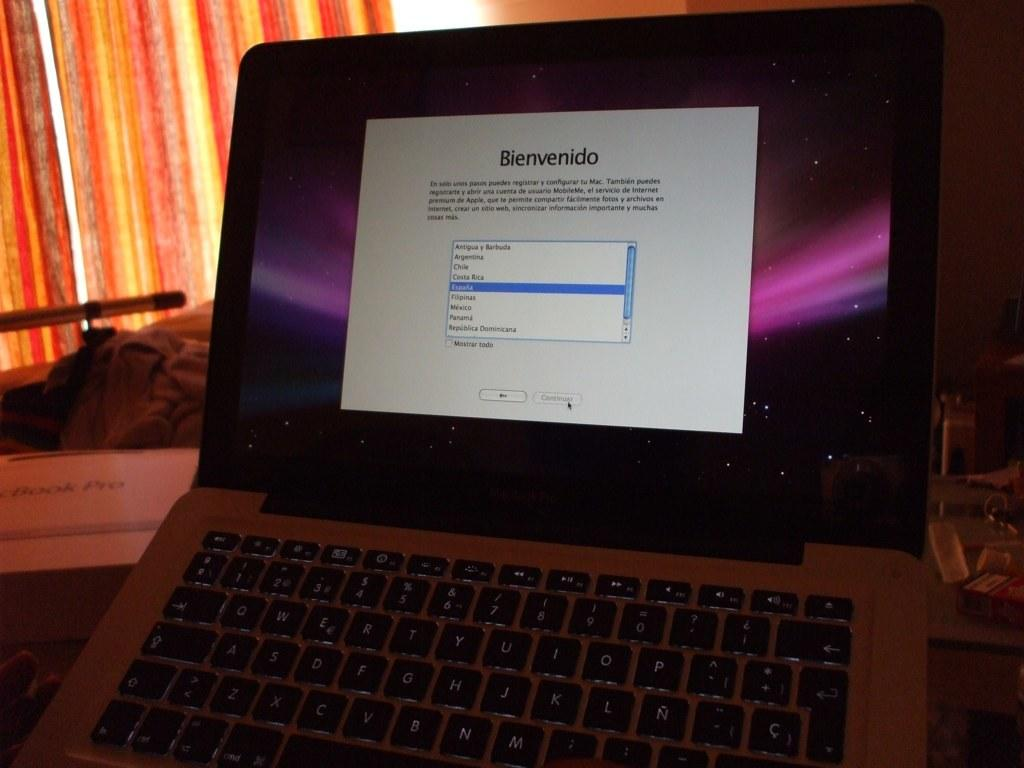<image>
Offer a succinct explanation of the picture presented. The title on the screen on the computer is Bienvenido. 